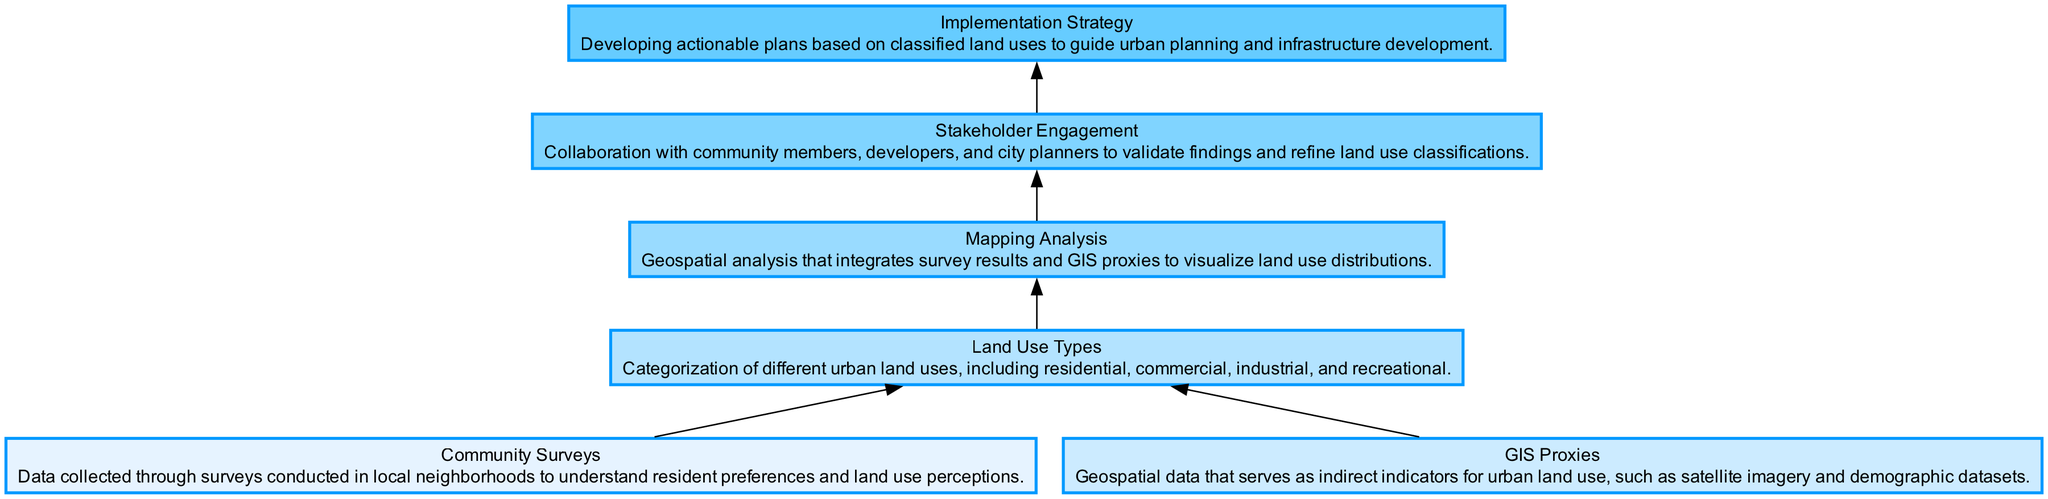What is the starting point of the flow chart? The flow chart starts with "Community Surveys," which is indicated as the first node in the diagram. The arrows leading from this node show it is the initial stage of the process.
Answer: Community Surveys How many elements are represented in the flow chart? By counting the nodes in the diagram, there are a total of six distinct elements: Community Surveys, GIS Proxies, Land Use Types, Mapping Analysis, Stakeholder Engagement, and Implementation Strategy.
Answer: Six What two nodes feed into "Land Use Types"? The arrows in the diagram indicate that both "Community Surveys" and "GIS Proxies" feed into "Land Use Types," which means these nodes are sources of information that contribute to understanding land use.
Answer: Community Surveys and GIS Proxies What is the final output of the flow chart? The last node in the flow chart is "Implementation Strategy," so the final output of the flow chart is the actionable plans developed based on the previous classifications.
Answer: Implementation Strategy Which node connects directly to "Mapping Analysis"? The flow chart shows that "Land Use Types" connects directly to "Mapping Analysis," signifying that this is the immediate step following the categorization of land uses.
Answer: Land Use Types Which element represents stakeholder collaboration? The node labeled "Stakeholder Engagement" represents the process of engaging with community members and other stakeholders to validate findings from the previous analyses.
Answer: Stakeholder Engagement What process follows "Mapping Analysis"? According to the flow chart, "Stakeholder Engagement" follows "Mapping Analysis," indicating that after mapping, collaboration with stakeholders is required.
Answer: Stakeholder Engagement In what order do the nodes appear? The order of the nodes from top to bottom is: Community Surveys, GIS Proxies, Land Use Types, Mapping Analysis, Stakeholder Engagement, Implementation Strategy, showing a clear progression from data collection to strategy implementation.
Answer: Community Surveys, GIS Proxies, Land Use Types, Mapping Analysis, Stakeholder Engagement, Implementation Strategy 